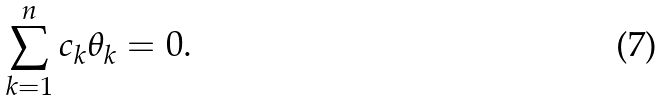<formula> <loc_0><loc_0><loc_500><loc_500>\sum _ { k = 1 } ^ { n } c _ { k } \theta _ { k } = 0 .</formula> 